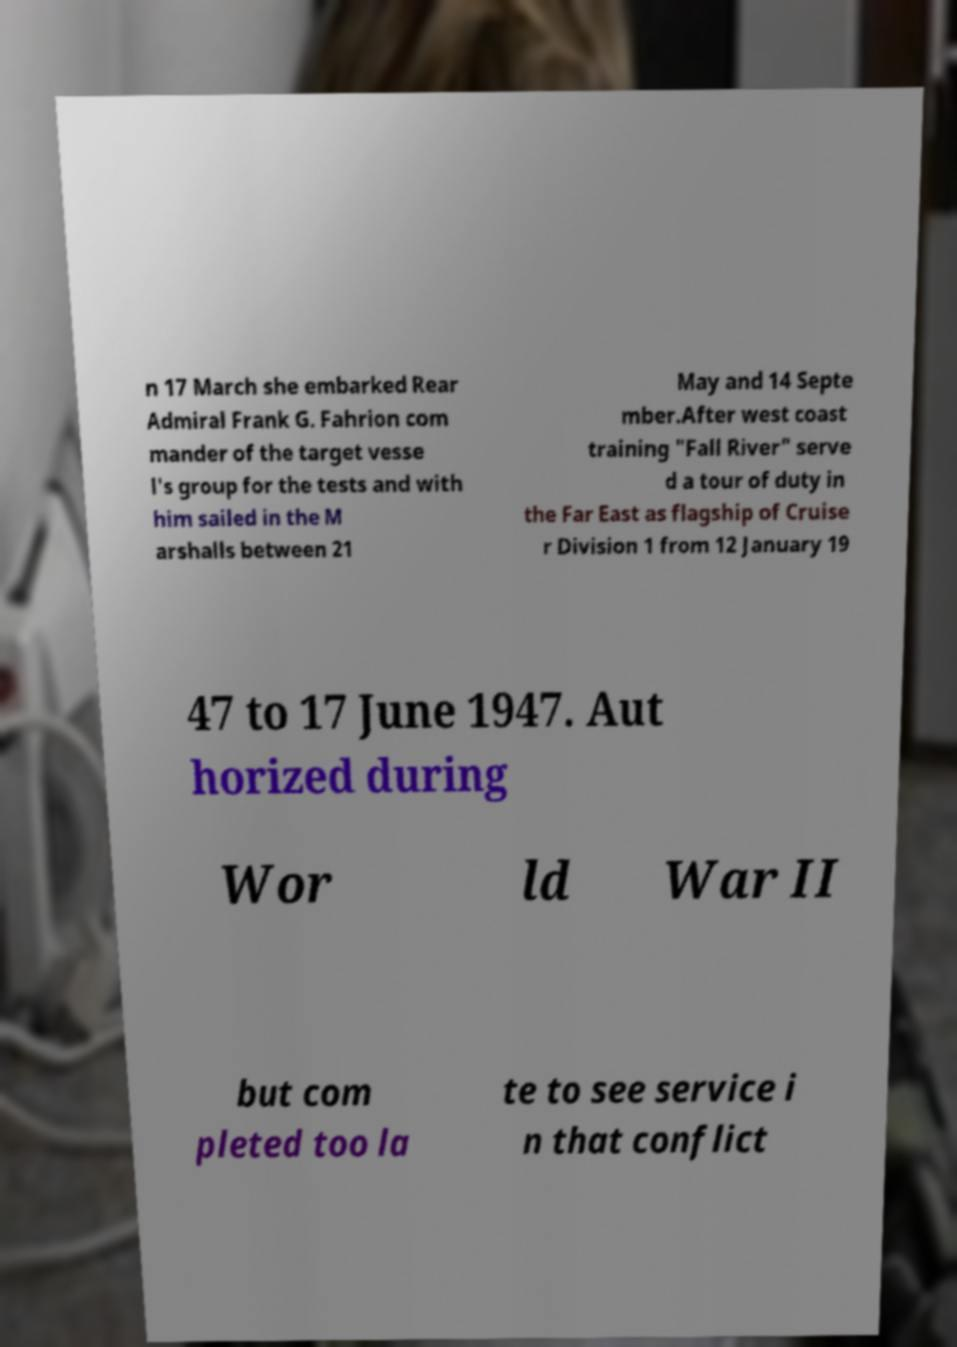Please identify and transcribe the text found in this image. n 17 March she embarked Rear Admiral Frank G. Fahrion com mander of the target vesse l's group for the tests and with him sailed in the M arshalls between 21 May and 14 Septe mber.After west coast training "Fall River" serve d a tour of duty in the Far East as flagship of Cruise r Division 1 from 12 January 19 47 to 17 June 1947. Aut horized during Wor ld War II but com pleted too la te to see service i n that conflict 